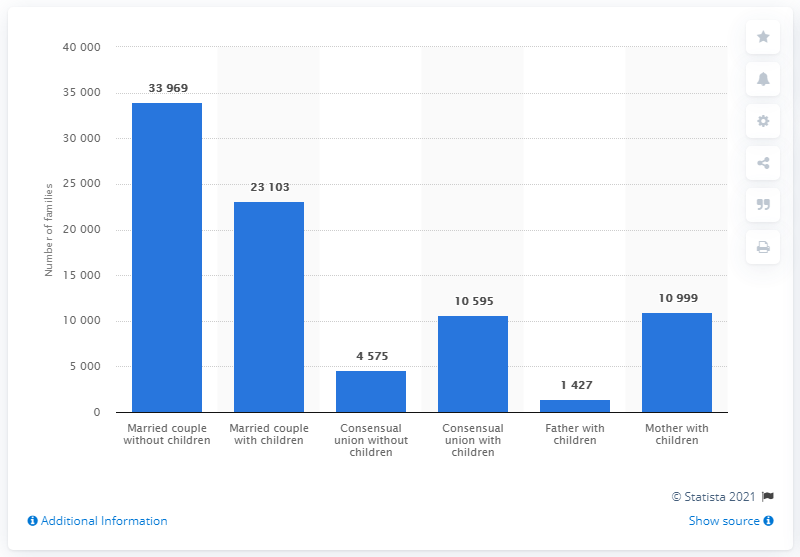List a handful of essential elements in this visual. In 2020, there were approximately 23,103 families in Iceland that consisted of a married couple and children. 